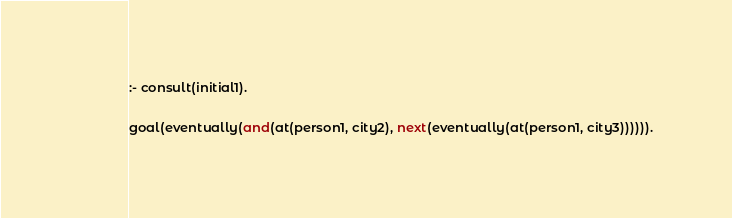<code> <loc_0><loc_0><loc_500><loc_500><_Perl_>:- consult(initial1).

goal(eventually(and(at(person1, city2), next(eventually(at(person1, city3)))))).
</code> 